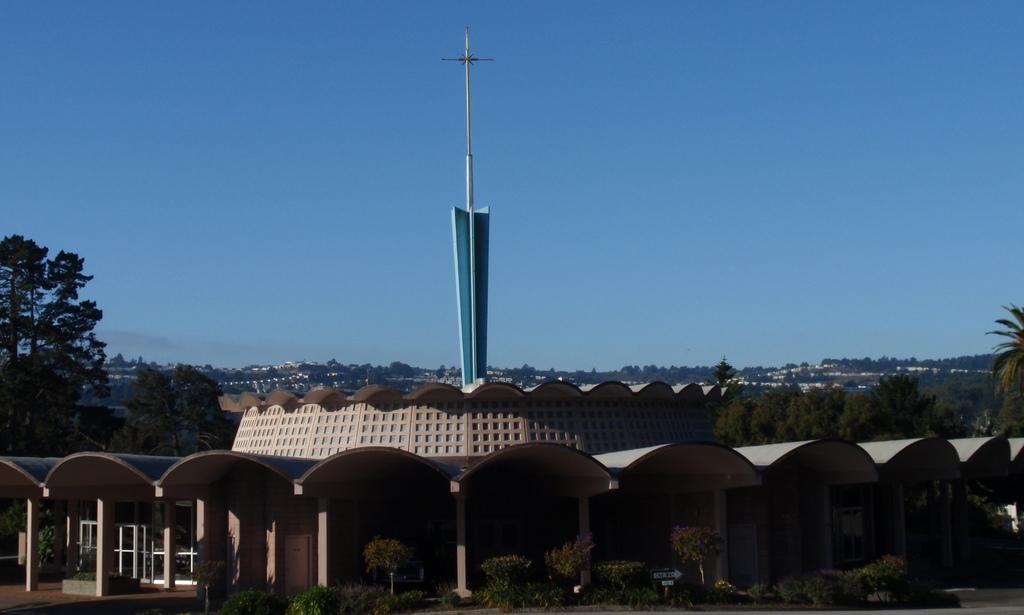What type of structure is present in the image? There is a building in the image. What other elements can be seen in the image besides the building? There are plants, a board, trees, and buildings in the background of the image. What is visible in the background of the image? The sky is visible in the background of the image. How far is the elbow of the person in the image from the board? There is no person present in the image, so it is not possible to determine the distance between an elbow and the board. 